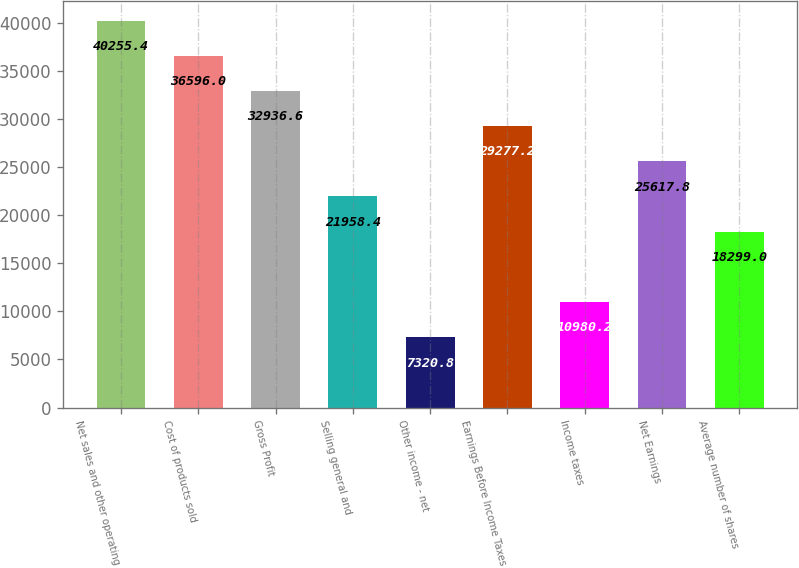Convert chart. <chart><loc_0><loc_0><loc_500><loc_500><bar_chart><fcel>Net sales and other operating<fcel>Cost of products sold<fcel>Gross Profit<fcel>Selling general and<fcel>Other income - net<fcel>Earnings Before Income Taxes<fcel>Income taxes<fcel>Net Earnings<fcel>Average number of shares<nl><fcel>40255.4<fcel>36596<fcel>32936.6<fcel>21958.4<fcel>7320.8<fcel>29277.2<fcel>10980.2<fcel>25617.8<fcel>18299<nl></chart> 